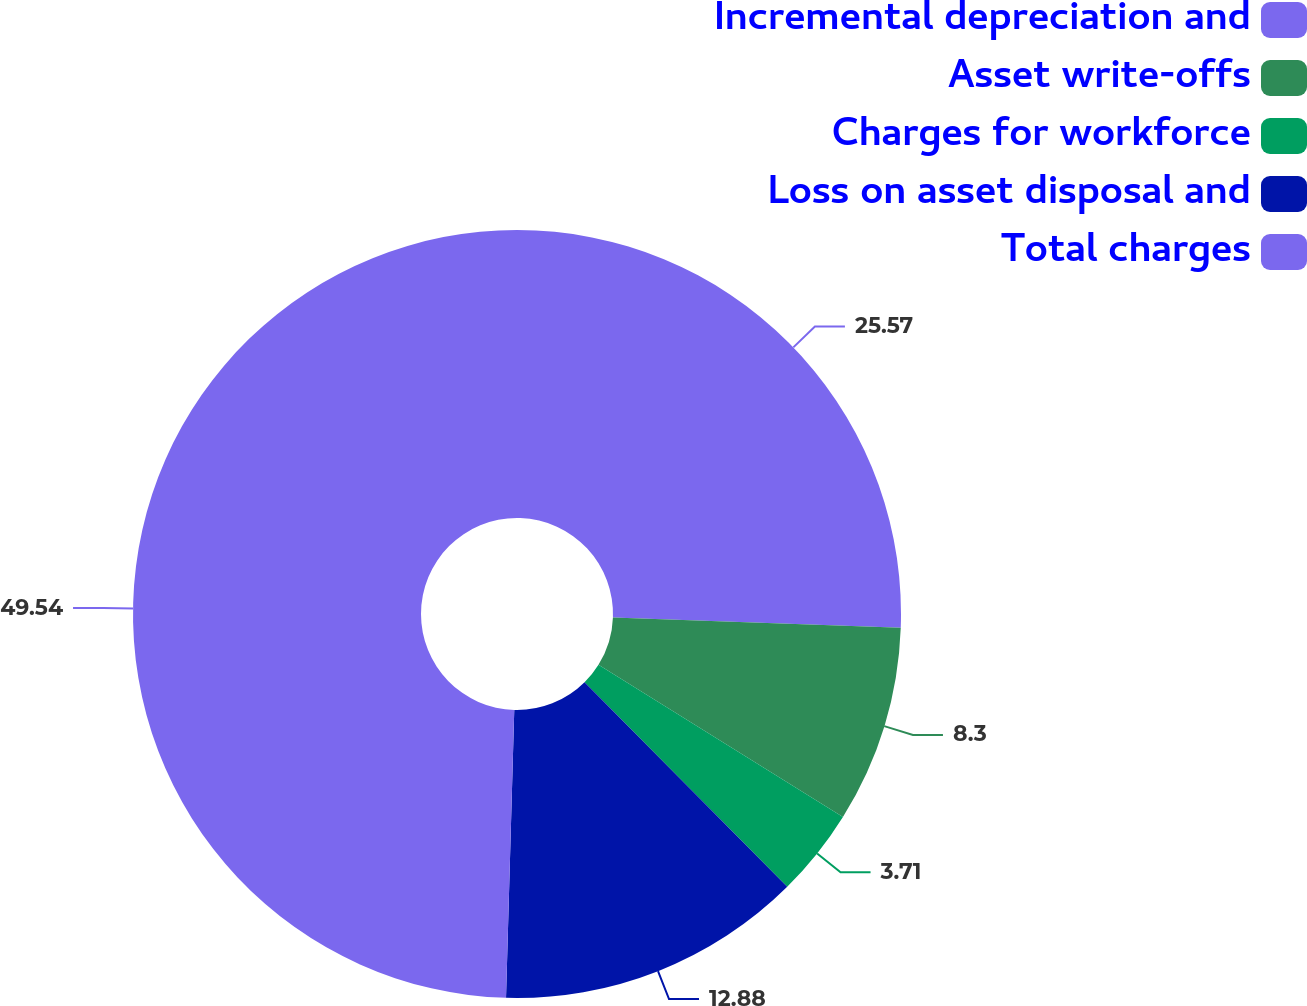Convert chart to OTSL. <chart><loc_0><loc_0><loc_500><loc_500><pie_chart><fcel>Incremental depreciation and<fcel>Asset write-offs<fcel>Charges for workforce<fcel>Loss on asset disposal and<fcel>Total charges<nl><fcel>25.57%<fcel>8.3%<fcel>3.71%<fcel>12.88%<fcel>49.55%<nl></chart> 